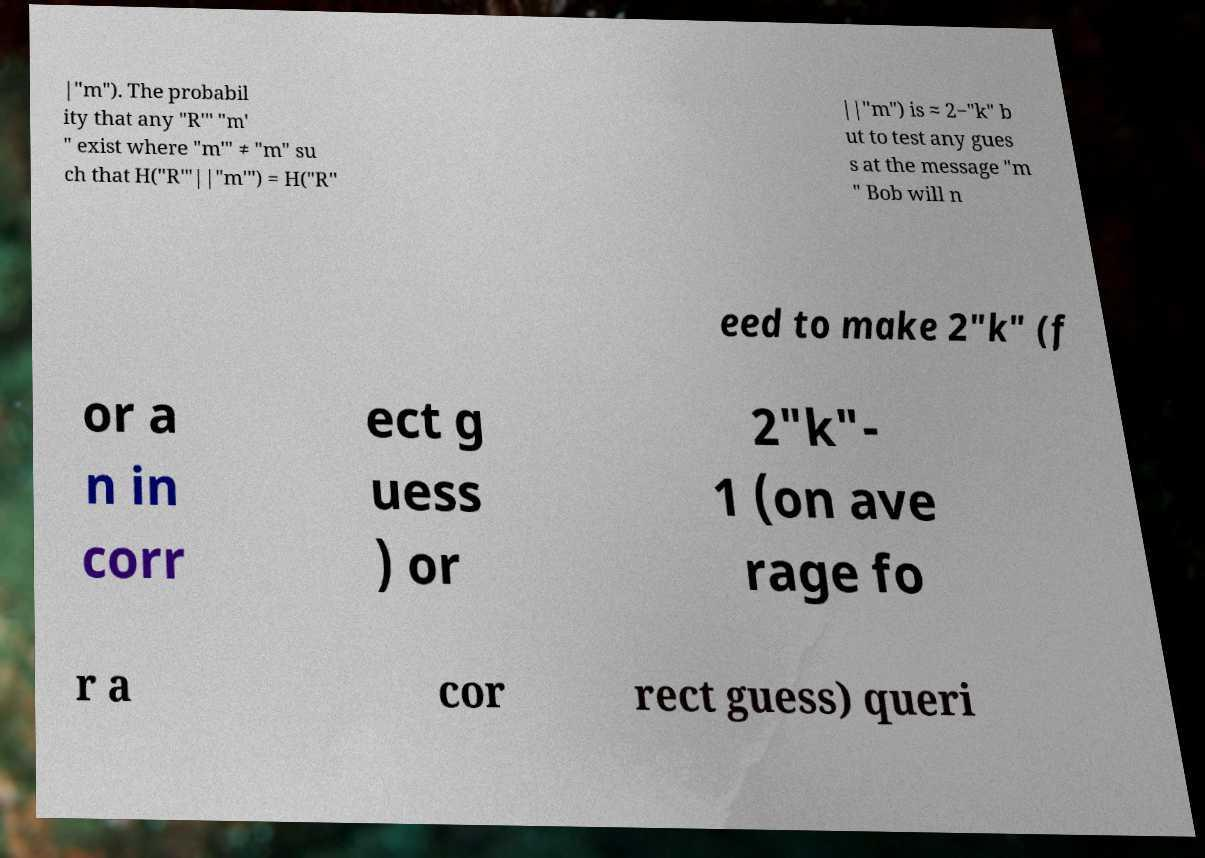For documentation purposes, I need the text within this image transcribed. Could you provide that? |"m"). The probabil ity that any "R′" "m′ " exist where "m′" ≠ "m" su ch that H("R′"||"m′") = H("R" ||"m") is ≈ 2−"k" b ut to test any gues s at the message "m " Bob will n eed to make 2"k" (f or a n in corr ect g uess ) or 2"k"- 1 (on ave rage fo r a cor rect guess) queri 